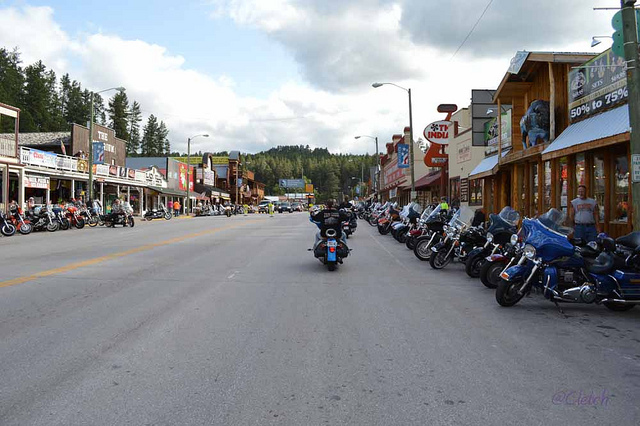<image>What job do all of the people on motorcycles have? I don't know what jobs all the people on motorcycles have. They could be bikers, mechanics or dealers. What job do all of the people on motorcycles have? I am not sure what job do all of the people on motorcycles have. It can be mechanic, dealer, biker, or they are just riding for fun. 